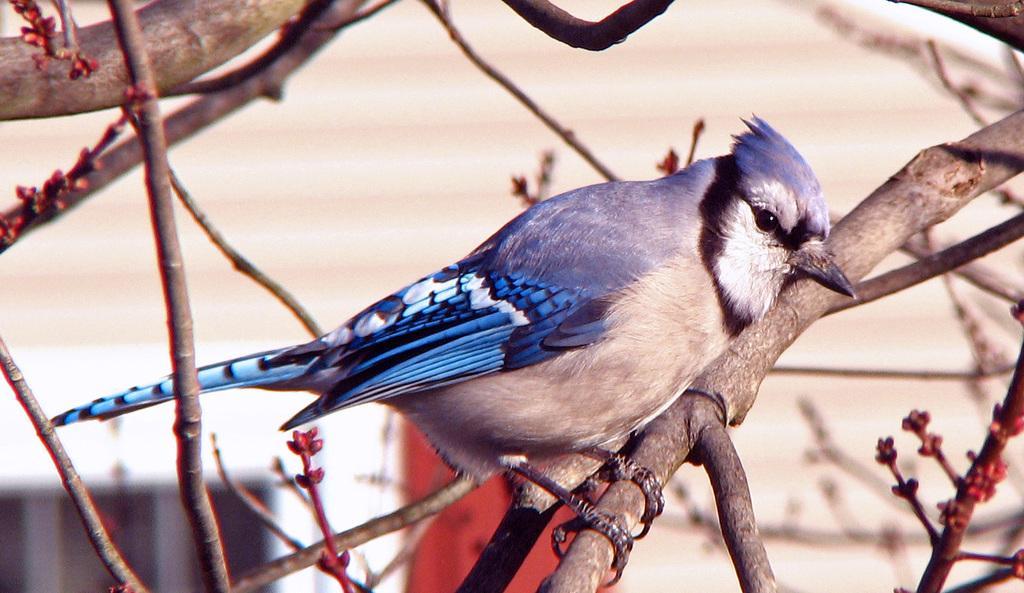In one or two sentences, can you explain what this image depicts? In this image I can see a bird which is blue, white , black and cream in color is on a tree branch which is brown and red in color. In the background I can see the cream colored surface. 